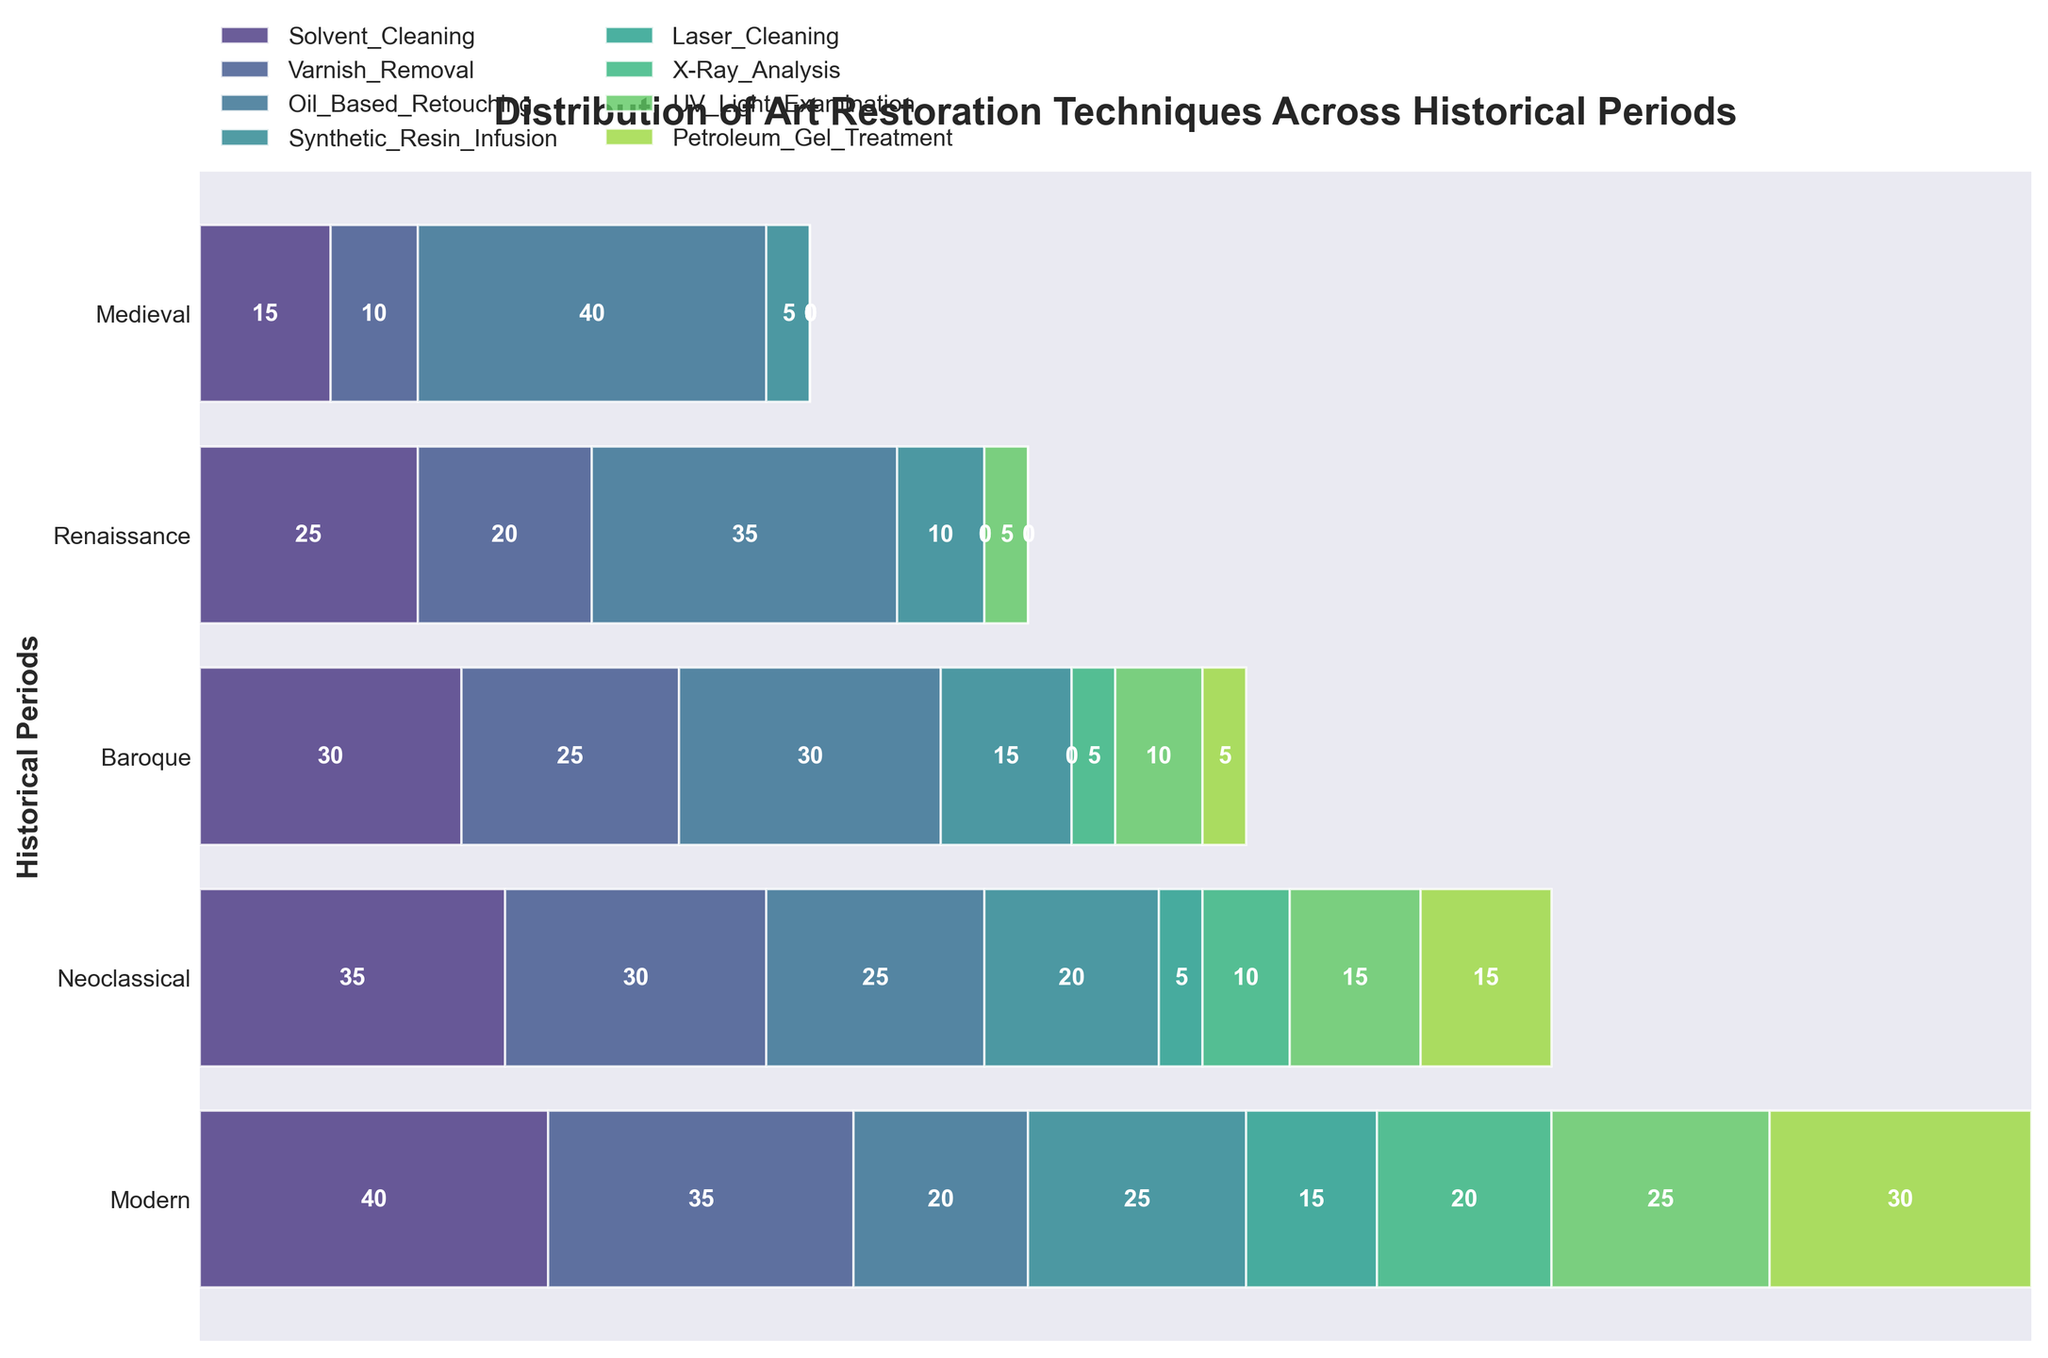Which historical period has the most use of "Oil-Based Retouching"? To determine this, locate the segment labeled "Oil-Based Retouching" and find the longest bar corresponding to the historical periods.
Answer: Medieval What is the total use of "Laser Cleaning" across all historical periods? Sum the heights of the bars labeled "Laser Cleaning" across all periods: 0 (Medieval) + 0 (Renaissance) + 0 (Baroque) + 5 (Neoclassical) + 15 (Modern) = 20.
Answer: 20 How does the use of "Synthetic Resin Infusion" change from the Baroque to the Modern period? Find the "Synthetic Resin Infusion" segments for Baroque and Modern periods: Baroque (15) and Modern (25). The change is calculated as 25 - 15 = 10.
Answer: Increases by 10 Which restoration technique sees a consistent increase in use over the historical periods? Check which segments grow progressively larger from left (Medieval) to right (Modern). "Petroleum Gel Treatment" fits this description, going from 0 to larger bars consistently.
Answer: Petroleum Gel Treatment Compare the use of "Varnish Removal" and "UV Light Examination" in the Baroque period. Which one is used more? Identify the Baroque segments for both techniques: "Varnish Removal" (25) and "UV Light Examination" (10). "Varnish Removal" has a larger bar.
Answer: Varnish Removal What is the most commonly used technique in the Renaissance period? By comparing the width of segments in the Renaissance period, "Oil-Based Retouching" is the widest.
Answer: Oil-Based Retouching How many restoration techniques are present in the Modern period? Count the number of distinct bars in the Modern period. Each bar represents a unique technique.
Answer: 8 What is the least used technique in the Medieval period? Identify the smallest or zero-height segment in the Medieval period. Many techniques have 0, but "Laser Cleaning," “X-Ray Analysis,” “UV Light Examination,” and “Petroleum Gel Treatment” all fit this description.
Answer: Laser Cleaning (and others) If you sum the uses of "Varnish Removal" in the Medieval and Neoclassical periods, what is the total? Add the bar heights for "Varnish Removal" in both periods: Medieval (10) + Neoclassical (30) = 40.
Answer: 40 